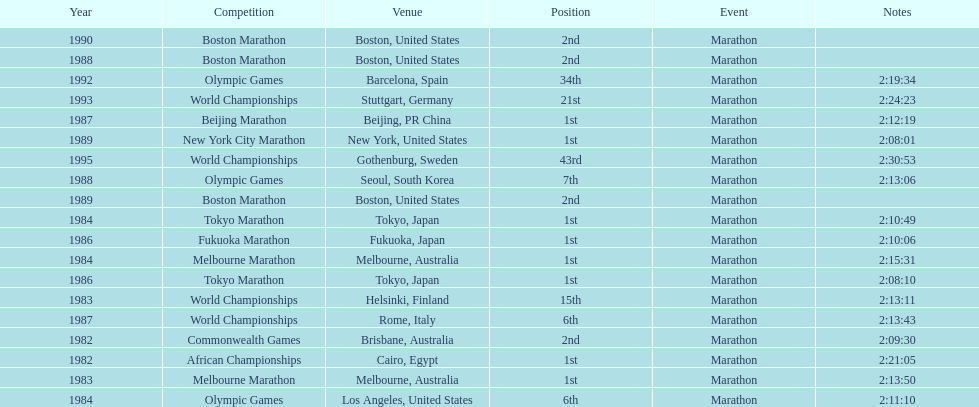What were the number of times the venue was located in the united states? 5. 